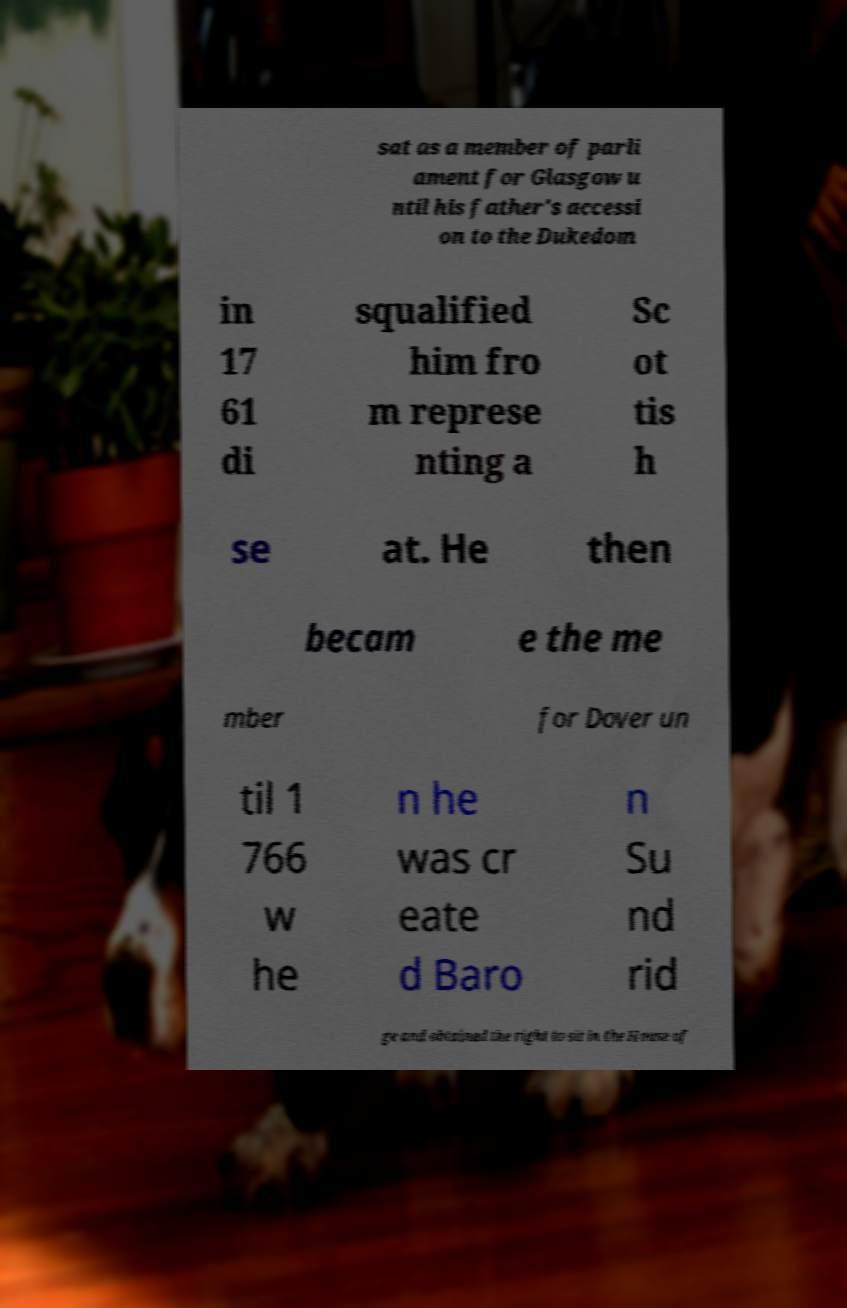There's text embedded in this image that I need extracted. Can you transcribe it verbatim? sat as a member of parli ament for Glasgow u ntil his father's accessi on to the Dukedom in 17 61 di squalified him fro m represe nting a Sc ot tis h se at. He then becam e the me mber for Dover un til 1 766 w he n he was cr eate d Baro n Su nd rid ge and obtained the right to sit in the House of 